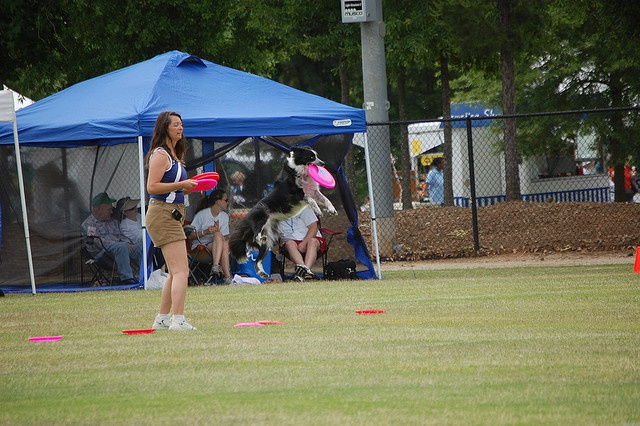Describe the objects in this image and their specific colors. I can see people in black, gray, and tan tones, dog in black, gray, and darkgray tones, people in black, gray, darkblue, and navy tones, people in black, gray, and darkgray tones, and people in black, darkgray, and gray tones in this image. 